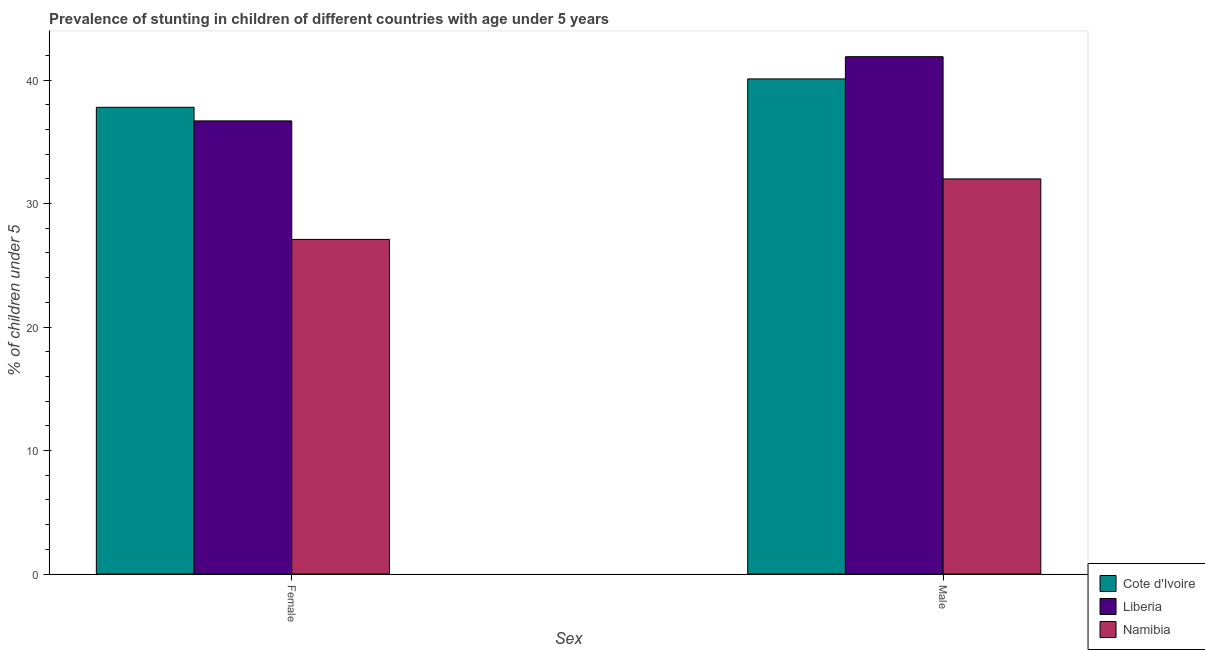How many groups of bars are there?
Provide a short and direct response. 2. Are the number of bars per tick equal to the number of legend labels?
Make the answer very short. Yes. Are the number of bars on each tick of the X-axis equal?
Offer a very short reply. Yes. What is the label of the 1st group of bars from the left?
Ensure brevity in your answer.  Female. What is the percentage of stunted female children in Namibia?
Your answer should be very brief. 27.1. Across all countries, what is the maximum percentage of stunted male children?
Provide a short and direct response. 41.9. Across all countries, what is the minimum percentage of stunted female children?
Provide a succinct answer. 27.1. In which country was the percentage of stunted male children maximum?
Provide a short and direct response. Liberia. In which country was the percentage of stunted male children minimum?
Your answer should be compact. Namibia. What is the total percentage of stunted female children in the graph?
Offer a very short reply. 101.6. What is the difference between the percentage of stunted male children in Cote d'Ivoire and that in Namibia?
Provide a succinct answer. 8.1. What is the difference between the percentage of stunted female children in Liberia and the percentage of stunted male children in Namibia?
Provide a short and direct response. 4.7. What is the average percentage of stunted male children per country?
Offer a terse response. 38. What is the difference between the percentage of stunted male children and percentage of stunted female children in Namibia?
Provide a succinct answer. 4.9. In how many countries, is the percentage of stunted male children greater than 20 %?
Make the answer very short. 3. What is the ratio of the percentage of stunted female children in Namibia to that in Liberia?
Your answer should be compact. 0.74. In how many countries, is the percentage of stunted male children greater than the average percentage of stunted male children taken over all countries?
Keep it short and to the point. 2. What does the 2nd bar from the left in Male represents?
Offer a very short reply. Liberia. What does the 1st bar from the right in Male represents?
Keep it short and to the point. Namibia. How many bars are there?
Your answer should be compact. 6. Are all the bars in the graph horizontal?
Offer a terse response. No. How many countries are there in the graph?
Provide a succinct answer. 3. What is the difference between two consecutive major ticks on the Y-axis?
Offer a terse response. 10. Are the values on the major ticks of Y-axis written in scientific E-notation?
Make the answer very short. No. Does the graph contain grids?
Your answer should be very brief. No. Where does the legend appear in the graph?
Your answer should be compact. Bottom right. What is the title of the graph?
Offer a terse response. Prevalence of stunting in children of different countries with age under 5 years. What is the label or title of the X-axis?
Your answer should be very brief. Sex. What is the label or title of the Y-axis?
Keep it short and to the point.  % of children under 5. What is the  % of children under 5 in Cote d'Ivoire in Female?
Offer a terse response. 37.8. What is the  % of children under 5 in Liberia in Female?
Offer a terse response. 36.7. What is the  % of children under 5 of Namibia in Female?
Provide a succinct answer. 27.1. What is the  % of children under 5 in Cote d'Ivoire in Male?
Keep it short and to the point. 40.1. What is the  % of children under 5 of Liberia in Male?
Your response must be concise. 41.9. What is the  % of children under 5 of Namibia in Male?
Provide a short and direct response. 32. Across all Sex, what is the maximum  % of children under 5 of Cote d'Ivoire?
Your answer should be very brief. 40.1. Across all Sex, what is the maximum  % of children under 5 of Liberia?
Your response must be concise. 41.9. Across all Sex, what is the maximum  % of children under 5 of Namibia?
Provide a short and direct response. 32. Across all Sex, what is the minimum  % of children under 5 of Cote d'Ivoire?
Offer a very short reply. 37.8. Across all Sex, what is the minimum  % of children under 5 of Liberia?
Ensure brevity in your answer.  36.7. Across all Sex, what is the minimum  % of children under 5 of Namibia?
Ensure brevity in your answer.  27.1. What is the total  % of children under 5 of Cote d'Ivoire in the graph?
Give a very brief answer. 77.9. What is the total  % of children under 5 of Liberia in the graph?
Ensure brevity in your answer.  78.6. What is the total  % of children under 5 in Namibia in the graph?
Make the answer very short. 59.1. What is the difference between the  % of children under 5 of Cote d'Ivoire in Female and that in Male?
Your answer should be very brief. -2.3. What is the difference between the  % of children under 5 of Liberia in Female and that in Male?
Give a very brief answer. -5.2. What is the difference between the  % of children under 5 of Cote d'Ivoire in Female and the  % of children under 5 of Liberia in Male?
Your response must be concise. -4.1. What is the difference between the  % of children under 5 of Liberia in Female and the  % of children under 5 of Namibia in Male?
Your answer should be compact. 4.7. What is the average  % of children under 5 in Cote d'Ivoire per Sex?
Your answer should be compact. 38.95. What is the average  % of children under 5 in Liberia per Sex?
Your answer should be very brief. 39.3. What is the average  % of children under 5 of Namibia per Sex?
Offer a terse response. 29.55. What is the difference between the  % of children under 5 of Liberia and  % of children under 5 of Namibia in Female?
Your response must be concise. 9.6. What is the difference between the  % of children under 5 of Cote d'Ivoire and  % of children under 5 of Namibia in Male?
Offer a very short reply. 8.1. What is the ratio of the  % of children under 5 of Cote d'Ivoire in Female to that in Male?
Provide a succinct answer. 0.94. What is the ratio of the  % of children under 5 in Liberia in Female to that in Male?
Provide a succinct answer. 0.88. What is the ratio of the  % of children under 5 of Namibia in Female to that in Male?
Provide a short and direct response. 0.85. What is the difference between the highest and the second highest  % of children under 5 of Liberia?
Keep it short and to the point. 5.2. What is the difference between the highest and the lowest  % of children under 5 of Cote d'Ivoire?
Ensure brevity in your answer.  2.3. What is the difference between the highest and the lowest  % of children under 5 of Namibia?
Provide a short and direct response. 4.9. 